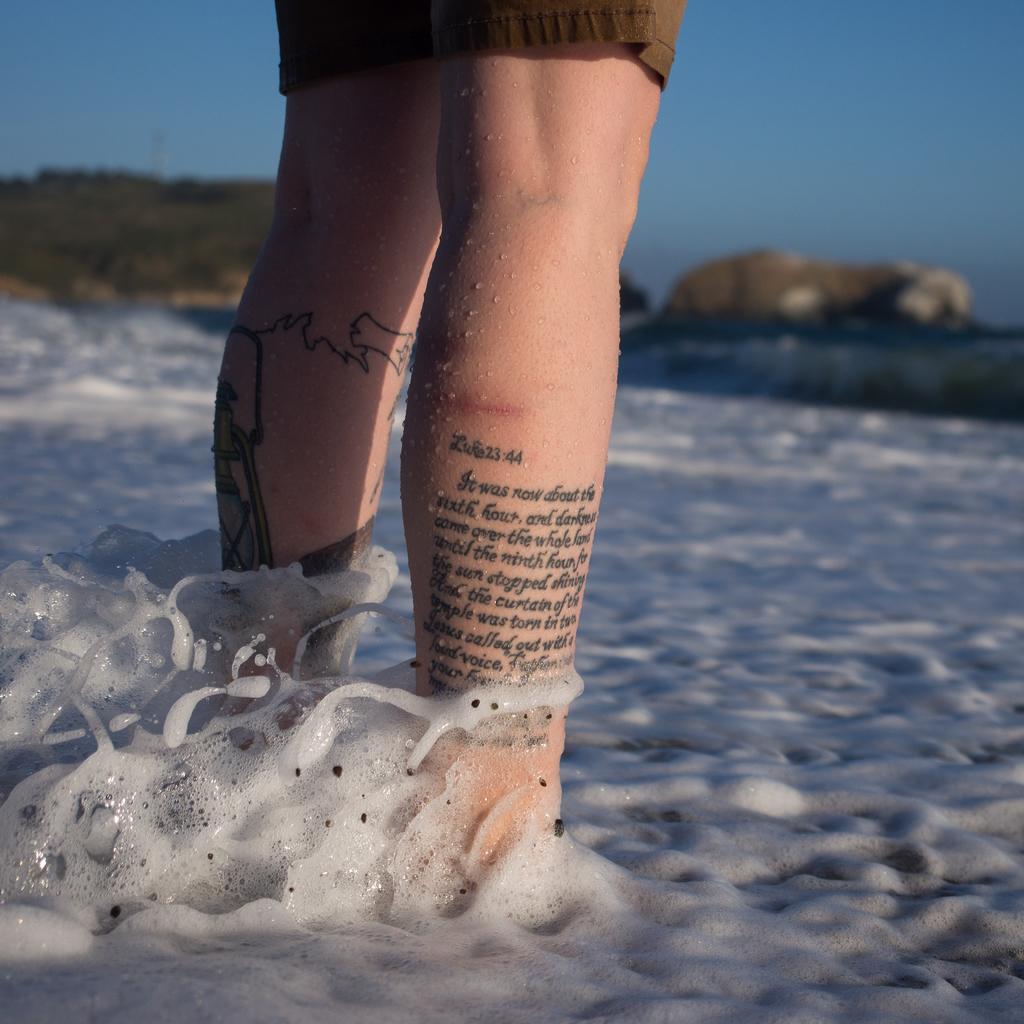How would you summarize this image in a sentence or two? In this image in the center there is a person standing and on the leg of the person there is some text written on the the leg and there is water in the front. 